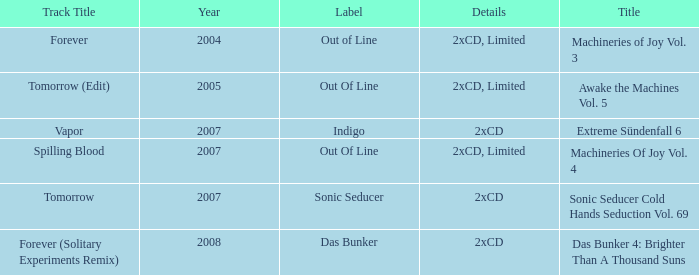What average year contains the title of machineries of joy vol. 4? 2007.0. 